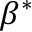<formula> <loc_0><loc_0><loc_500><loc_500>\beta ^ { * }</formula> 